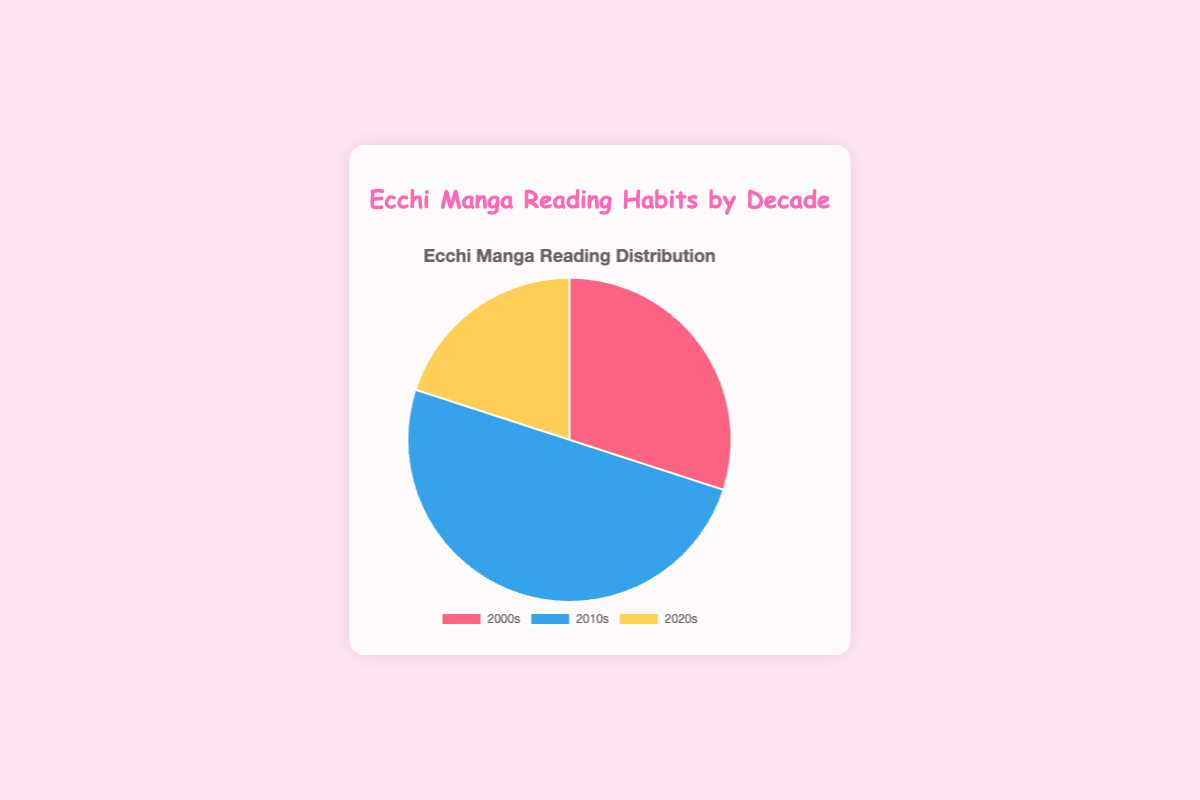What decade has the highest relative amount of ecchi manga read? The pie chart shows that the 2010s have the largest segment, indicating the highest relative amount of ecchi manga read.
Answer: 2010s What is the combined relative amount of ecchi manga read in the 2000s and 2020s? According to the pie chart, the relative amount of ecchi manga read in the 2000s is 30% and in the 2020s is 20%. Adding these together gives us 30% + 20% = 50%.
Answer: 50% How does the relative amount of ecchi manga read in the 2020s compare to the 2000s? The pie chart shows that 30% of ecchi manga was read in the 2000s and 20% was read in the 2020s. We can see that 30% is greater than 20%, meaning more ecchi manga was read in the 2000s compared to the 2020s.
Answer: 2000s is greater Which segment is represented by the red color in the pie chart? The pie chart uses different colors to represent the decades, with the red segment representing the 2000s.
Answer: 2000s What fraction of the total ecchi manga read comes from the decade with the least amount? The pie chart shows that the decade with the least amount of ecchi manga read is the 2020s (20%). This fraction out of the total 100% would be 20/100, which simplifies to 1/5.
Answer: 1/5 If the data were converted into actual numbers with a total of 100 manga read, how many ecchi manga from the 2010s were read? The pie chart indicates that 50% of the ecchi manga read came from the 2010s. If 100 total manga were read, then 0.50 x 100 = 50 manga from the 2010s were read.
Answer: 50 What is the difference in the relative amount of ecchi manga read between the 2000s and the 2020s? According to the pie chart, the 2000s have 30% and the 2020s have 20%. The difference is 30% - 20% = 10%.
Answer: 10% Among the three decades, which one has the smallest share of ecchi manga read? From the pie chart, the 2020s have the smallest segment, indicating the smallest share of ecchi manga read at 20%.
Answer: 2020s What proportion of the total ecchi manga read come from the 2010s? The pie chart shows that 50% of the ecchi manga read comes from the 2010s. This corresponds to a proportion of 0.50 or 50/100.
Answer: 50% 